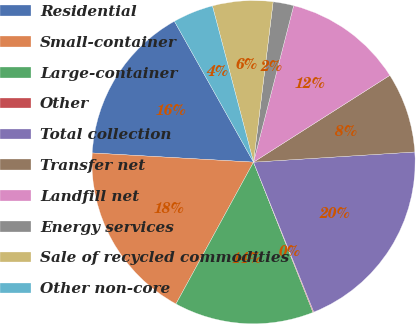Convert chart to OTSL. <chart><loc_0><loc_0><loc_500><loc_500><pie_chart><fcel>Residential<fcel>Small-container<fcel>Large-container<fcel>Other<fcel>Total collection<fcel>Transfer net<fcel>Landfill net<fcel>Energy services<fcel>Sale of recycled commodities<fcel>Other non-core<nl><fcel>15.95%<fcel>17.94%<fcel>13.97%<fcel>0.08%<fcel>19.92%<fcel>8.02%<fcel>11.98%<fcel>2.06%<fcel>6.03%<fcel>4.05%<nl></chart> 